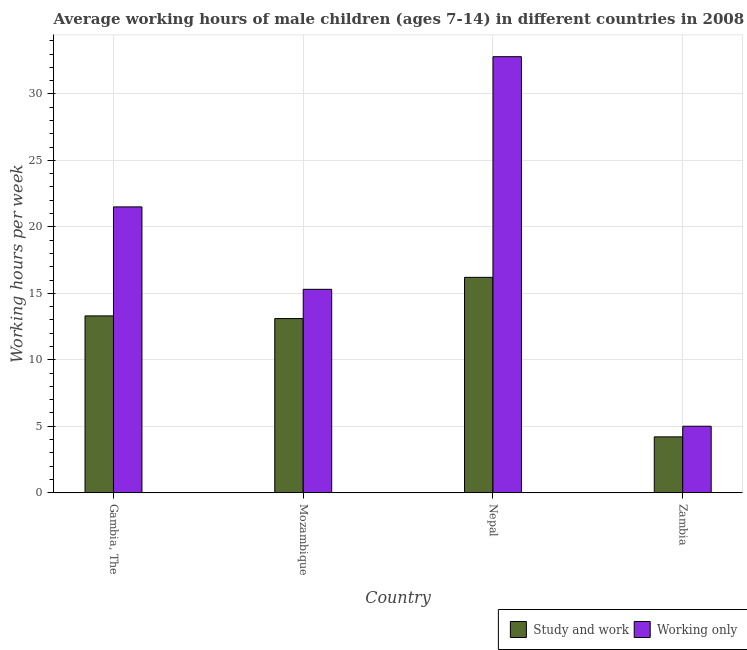How many different coloured bars are there?
Provide a short and direct response. 2. How many groups of bars are there?
Offer a terse response. 4. How many bars are there on the 2nd tick from the right?
Provide a succinct answer. 2. What is the label of the 3rd group of bars from the left?
Make the answer very short. Nepal. What is the average working hour of children involved in only work in Nepal?
Your answer should be compact. 32.8. Across all countries, what is the maximum average working hour of children involved in study and work?
Provide a short and direct response. 16.2. In which country was the average working hour of children involved in only work maximum?
Offer a very short reply. Nepal. In which country was the average working hour of children involved in only work minimum?
Make the answer very short. Zambia. What is the total average working hour of children involved in only work in the graph?
Make the answer very short. 74.6. What is the difference between the average working hour of children involved in only work in Nepal and the average working hour of children involved in study and work in Mozambique?
Keep it short and to the point. 19.7. What is the average average working hour of children involved in only work per country?
Give a very brief answer. 18.65. What is the difference between the average working hour of children involved in study and work and average working hour of children involved in only work in Zambia?
Provide a succinct answer. -0.8. What is the ratio of the average working hour of children involved in study and work in Mozambique to that in Zambia?
Your response must be concise. 3.12. Is the average working hour of children involved in only work in Mozambique less than that in Zambia?
Make the answer very short. No. What is the difference between the highest and the second highest average working hour of children involved in study and work?
Offer a terse response. 2.9. In how many countries, is the average working hour of children involved in study and work greater than the average average working hour of children involved in study and work taken over all countries?
Your answer should be compact. 3. Is the sum of the average working hour of children involved in study and work in Mozambique and Nepal greater than the maximum average working hour of children involved in only work across all countries?
Your answer should be compact. No. What does the 1st bar from the left in Zambia represents?
Offer a very short reply. Study and work. What does the 2nd bar from the right in Gambia, The represents?
Provide a short and direct response. Study and work. How many countries are there in the graph?
Your answer should be very brief. 4. What is the difference between two consecutive major ticks on the Y-axis?
Your answer should be very brief. 5. Does the graph contain grids?
Your answer should be compact. Yes. How many legend labels are there?
Your answer should be very brief. 2. How are the legend labels stacked?
Provide a succinct answer. Horizontal. What is the title of the graph?
Keep it short and to the point. Average working hours of male children (ages 7-14) in different countries in 2008. Does "Non-resident workers" appear as one of the legend labels in the graph?
Your answer should be compact. No. What is the label or title of the X-axis?
Offer a very short reply. Country. What is the label or title of the Y-axis?
Your answer should be compact. Working hours per week. What is the Working hours per week of Study and work in Gambia, The?
Provide a succinct answer. 13.3. What is the Working hours per week of Working only in Gambia, The?
Offer a terse response. 21.5. What is the Working hours per week of Study and work in Mozambique?
Provide a short and direct response. 13.1. What is the Working hours per week in Working only in Mozambique?
Your answer should be very brief. 15.3. What is the Working hours per week in Study and work in Nepal?
Your answer should be very brief. 16.2. What is the Working hours per week in Working only in Nepal?
Your answer should be very brief. 32.8. Across all countries, what is the maximum Working hours per week of Working only?
Offer a terse response. 32.8. Across all countries, what is the minimum Working hours per week in Working only?
Your answer should be very brief. 5. What is the total Working hours per week of Study and work in the graph?
Your answer should be compact. 46.8. What is the total Working hours per week of Working only in the graph?
Give a very brief answer. 74.6. What is the difference between the Working hours per week in Study and work in Gambia, The and that in Nepal?
Offer a very short reply. -2.9. What is the difference between the Working hours per week in Working only in Gambia, The and that in Nepal?
Your answer should be very brief. -11.3. What is the difference between the Working hours per week in Working only in Mozambique and that in Nepal?
Give a very brief answer. -17.5. What is the difference between the Working hours per week in Study and work in Mozambique and that in Zambia?
Offer a very short reply. 8.9. What is the difference between the Working hours per week in Working only in Mozambique and that in Zambia?
Provide a short and direct response. 10.3. What is the difference between the Working hours per week in Working only in Nepal and that in Zambia?
Give a very brief answer. 27.8. What is the difference between the Working hours per week in Study and work in Gambia, The and the Working hours per week in Working only in Mozambique?
Your response must be concise. -2. What is the difference between the Working hours per week in Study and work in Gambia, The and the Working hours per week in Working only in Nepal?
Your answer should be compact. -19.5. What is the difference between the Working hours per week of Study and work in Gambia, The and the Working hours per week of Working only in Zambia?
Make the answer very short. 8.3. What is the difference between the Working hours per week of Study and work in Mozambique and the Working hours per week of Working only in Nepal?
Your answer should be very brief. -19.7. What is the average Working hours per week in Study and work per country?
Keep it short and to the point. 11.7. What is the average Working hours per week of Working only per country?
Offer a terse response. 18.65. What is the difference between the Working hours per week in Study and work and Working hours per week in Working only in Gambia, The?
Your response must be concise. -8.2. What is the difference between the Working hours per week in Study and work and Working hours per week in Working only in Nepal?
Give a very brief answer. -16.6. What is the ratio of the Working hours per week of Study and work in Gambia, The to that in Mozambique?
Your answer should be compact. 1.02. What is the ratio of the Working hours per week in Working only in Gambia, The to that in Mozambique?
Provide a succinct answer. 1.41. What is the ratio of the Working hours per week in Study and work in Gambia, The to that in Nepal?
Offer a very short reply. 0.82. What is the ratio of the Working hours per week of Working only in Gambia, The to that in Nepal?
Provide a short and direct response. 0.66. What is the ratio of the Working hours per week of Study and work in Gambia, The to that in Zambia?
Provide a short and direct response. 3.17. What is the ratio of the Working hours per week of Working only in Gambia, The to that in Zambia?
Provide a short and direct response. 4.3. What is the ratio of the Working hours per week of Study and work in Mozambique to that in Nepal?
Offer a very short reply. 0.81. What is the ratio of the Working hours per week in Working only in Mozambique to that in Nepal?
Your answer should be very brief. 0.47. What is the ratio of the Working hours per week of Study and work in Mozambique to that in Zambia?
Your answer should be compact. 3.12. What is the ratio of the Working hours per week of Working only in Mozambique to that in Zambia?
Your answer should be very brief. 3.06. What is the ratio of the Working hours per week in Study and work in Nepal to that in Zambia?
Your answer should be compact. 3.86. What is the ratio of the Working hours per week of Working only in Nepal to that in Zambia?
Your response must be concise. 6.56. What is the difference between the highest and the second highest Working hours per week of Study and work?
Offer a very short reply. 2.9. What is the difference between the highest and the lowest Working hours per week of Working only?
Provide a succinct answer. 27.8. 